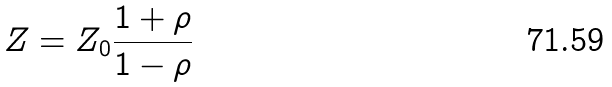<formula> <loc_0><loc_0><loc_500><loc_500>Z = Z _ { 0 } \frac { 1 + \rho } { 1 - \rho }</formula> 